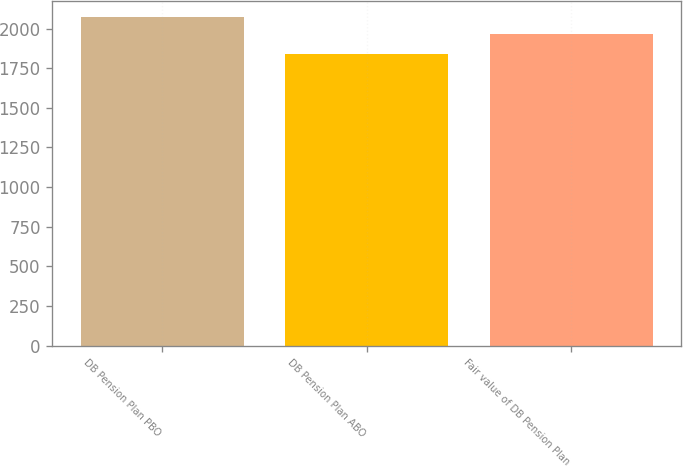<chart> <loc_0><loc_0><loc_500><loc_500><bar_chart><fcel>DB Pension Plan PBO<fcel>DB Pension Plan ABO<fcel>Fair value of DB Pension Plan<nl><fcel>2073<fcel>1843<fcel>1964<nl></chart> 